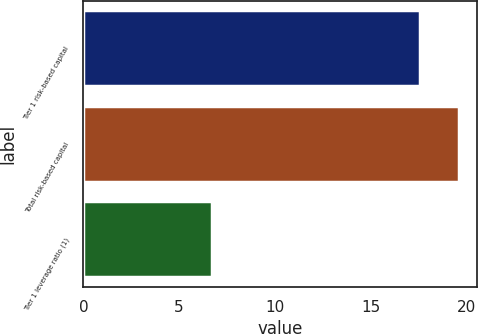Convert chart to OTSL. <chart><loc_0><loc_0><loc_500><loc_500><bar_chart><fcel>Tier 1 risk-based capital<fcel>Total risk-based capital<fcel>Tier 1 leverage ratio (1)<nl><fcel>17.6<fcel>19.6<fcel>6.7<nl></chart> 